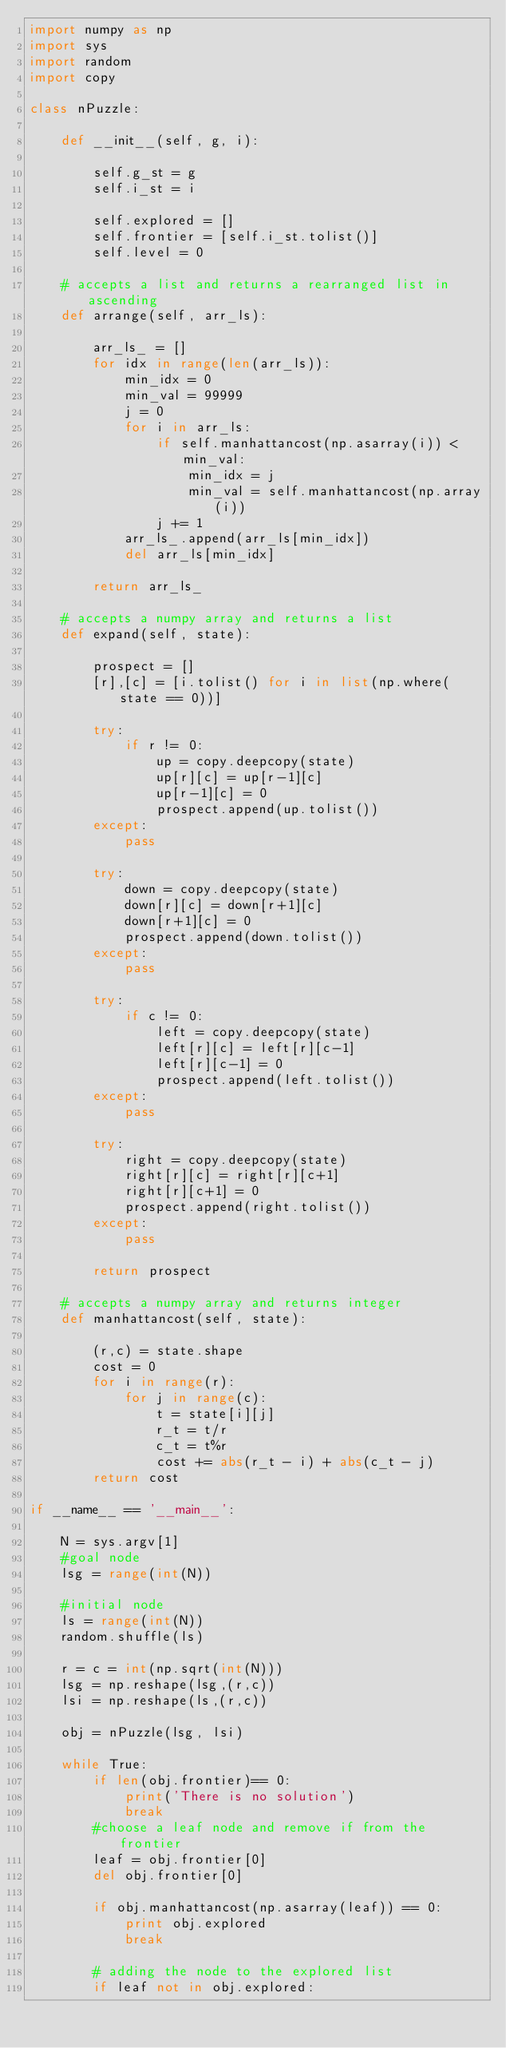Convert code to text. <code><loc_0><loc_0><loc_500><loc_500><_Python_>import numpy as np
import sys 
import random
import copy

class nPuzzle:

    def __init__(self, g, i):

        self.g_st = g 
        self.i_st = i

        self.explored = []
        self.frontier = [self.i_st.tolist()]
        self.level = 0
    
    # accepts a list and returns a rearranged list in ascending
    def arrange(self, arr_ls):
        
        arr_ls_ = []
        for idx in range(len(arr_ls)):
            min_idx = 0
            min_val = 99999
            j = 0
            for i in arr_ls:
                if self.manhattancost(np.asarray(i)) < min_val:
                    min_idx = j
                    min_val = self.manhattancost(np.array(i))
                j += 1
            arr_ls_.append(arr_ls[min_idx])
            del arr_ls[min_idx]
        
        return arr_ls_

    # accepts a numpy array and returns a list
    def expand(self, state):
        
        prospect = []
        [r],[c] = [i.tolist() for i in list(np.where(state == 0))]

        try:
            if r != 0:
                up = copy.deepcopy(state)
                up[r][c] = up[r-1][c]
                up[r-1][c] = 0
                prospect.append(up.tolist())
        except:
            pass

        try:
            down = copy.deepcopy(state)
            down[r][c] = down[r+1][c]
            down[r+1][c] = 0
            prospect.append(down.tolist())
        except:
            pass
        
        try:
            if c != 0:
                left = copy.deepcopy(state)
                left[r][c] = left[r][c-1]
                left[r][c-1] = 0
                prospect.append(left.tolist())
        except:
            pass

        try:
            right = copy.deepcopy(state)
            right[r][c] = right[r][c+1]
            right[r][c+1] = 0
            prospect.append(right.tolist())
        except:
            pass

        return prospect
    
    # accepts a numpy array and returns integer
    def manhattancost(self, state):
        
        (r,c) = state.shape
        cost = 0
        for i in range(r):
            for j in range(c):
                t = state[i][j]
                r_t = t/r
                c_t = t%r
                cost += abs(r_t - i) + abs(c_t - j)
        return cost

if __name__ == '__main__':

    N = sys.argv[1]
    #goal node
    lsg = range(int(N))

    #initial node 
    ls = range(int(N))
    random.shuffle(ls)

    r = c = int(np.sqrt(int(N)))
    lsg = np.reshape(lsg,(r,c))
    lsi = np.reshape(ls,(r,c))

    obj = nPuzzle(lsg, lsi)

    while True:
        if len(obj.frontier)== 0:
            print('There is no solution')
            break
        #choose a leaf node and remove if from the frontier
        leaf = obj.frontier[0]
        del obj.frontier[0]
        
        if obj.manhattancost(np.asarray(leaf)) == 0:
            print obj.explored
            break
    
        # adding the node to the explored list
        if leaf not in obj.explored:</code> 